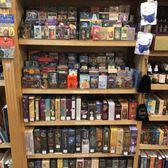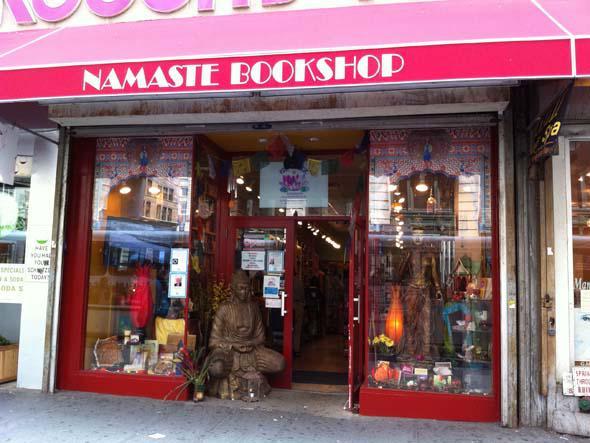The first image is the image on the left, the second image is the image on the right. Examine the images to the left and right. Is the description "Left image contains a person wearing a black blazer." accurate? Answer yes or no. No. The first image is the image on the left, the second image is the image on the right. Evaluate the accuracy of this statement regarding the images: "A woman with dark hair and wearing a black jacket is in a bookstore in one image.". Is it true? Answer yes or no. No. The first image is the image on the left, the second image is the image on the right. Evaluate the accuracy of this statement regarding the images: "There is one woman wearing black in the lefthand image.". Is it true? Answer yes or no. No. The first image is the image on the left, the second image is the image on the right. For the images shown, is this caption "there is exactly one person in the image on the left" true? Answer yes or no. No. 